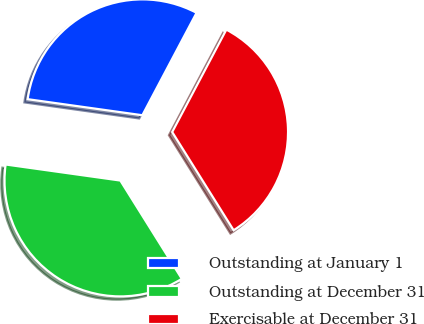Convert chart to OTSL. <chart><loc_0><loc_0><loc_500><loc_500><pie_chart><fcel>Outstanding at January 1<fcel>Outstanding at December 31<fcel>Exercisable at December 31<nl><fcel>30.53%<fcel>36.11%<fcel>33.36%<nl></chart> 